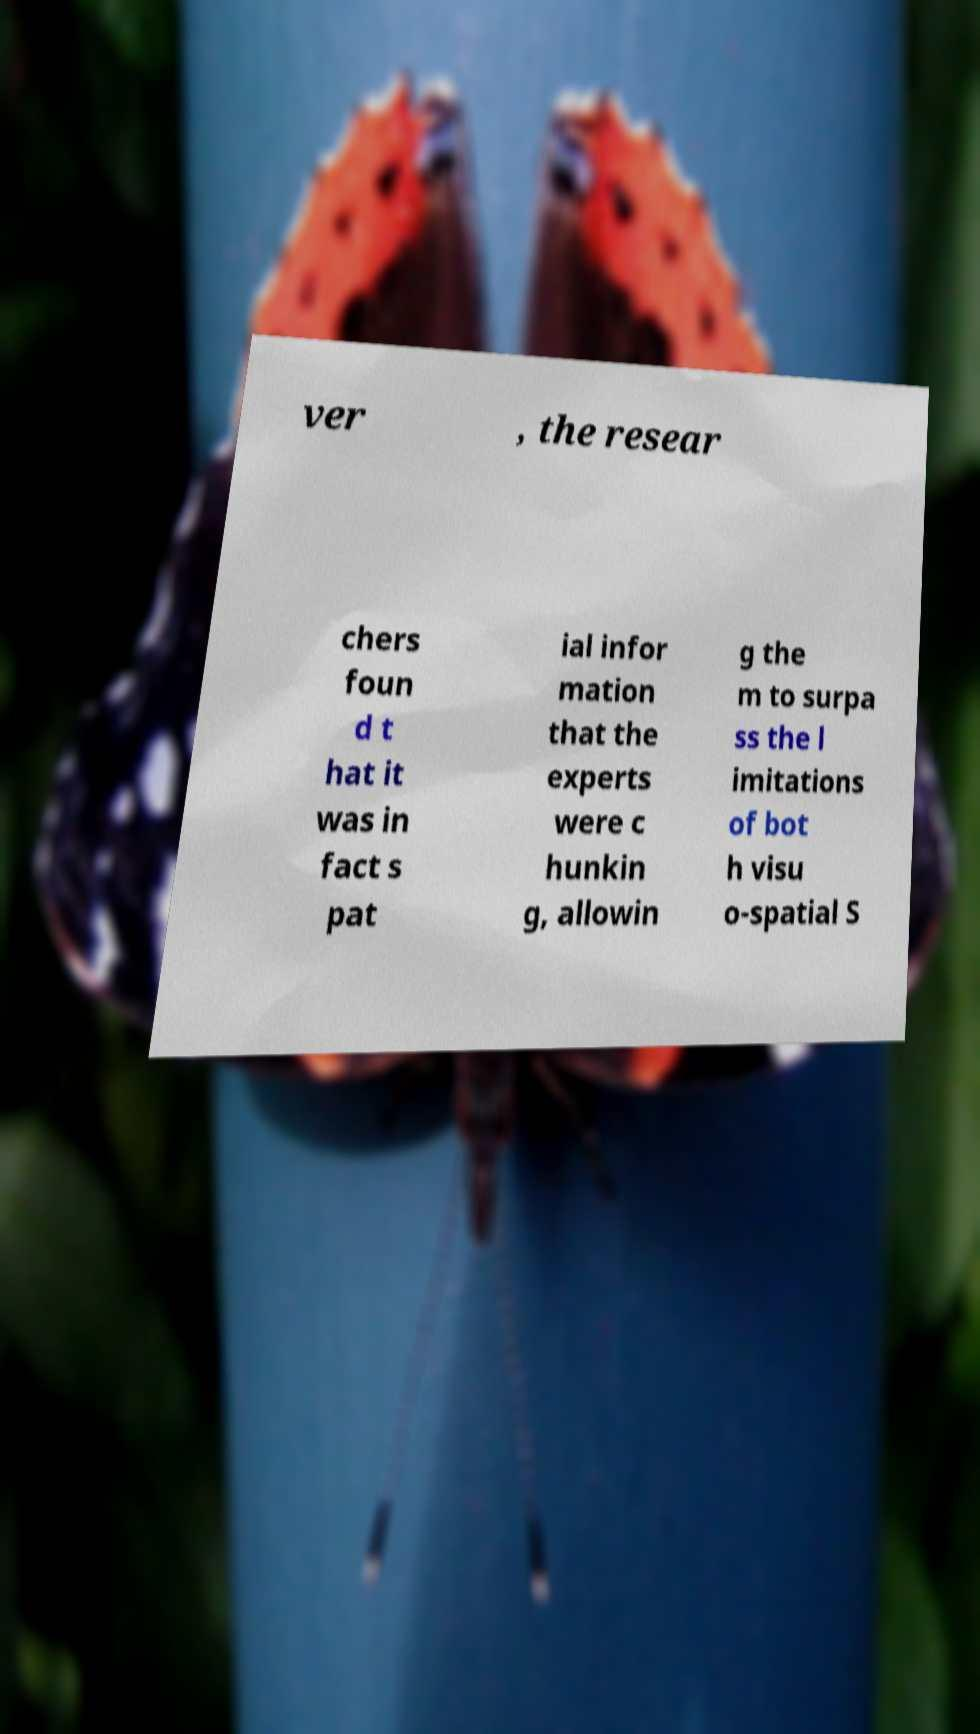What messages or text are displayed in this image? I need them in a readable, typed format. ver , the resear chers foun d t hat it was in fact s pat ial infor mation that the experts were c hunkin g, allowin g the m to surpa ss the l imitations of bot h visu o-spatial S 